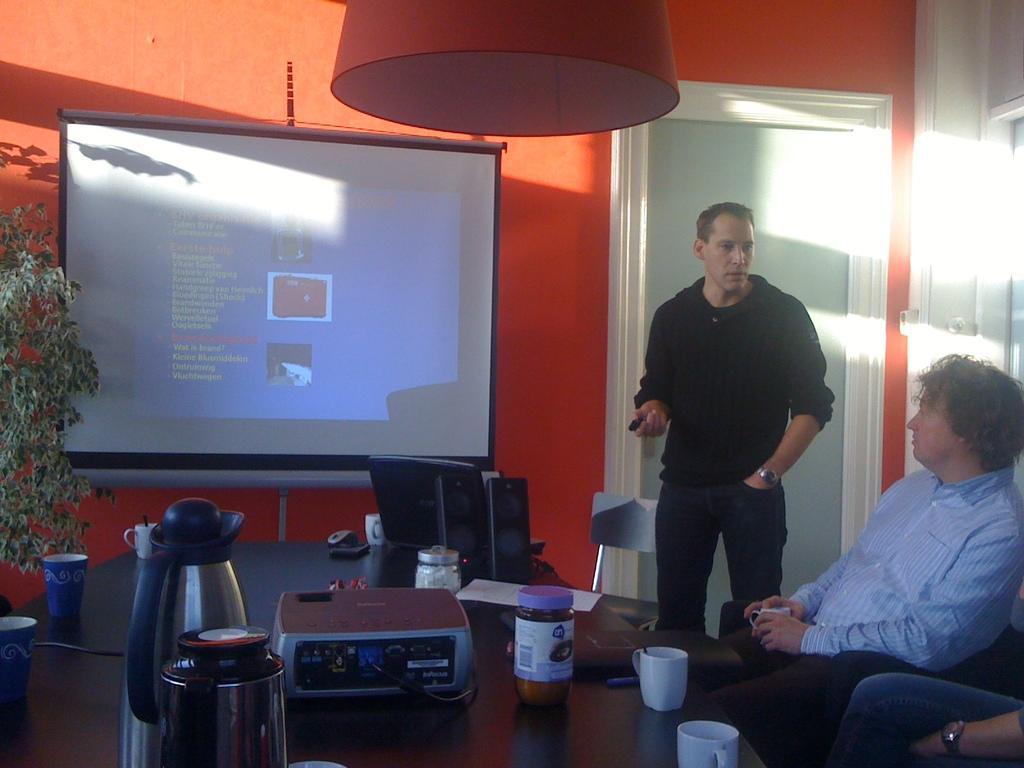Can you describe this image briefly? It looks like a room inside the office ,there is a projector screen and something is displayed on the screen, in front of that there is a black color table, on the table there is a flask, bottle, some cups and a projecting machine, to the right side that is a person sitting ,beside him there is a man standing and talking to him in the background there is orange color light and sunlight is falling on that wall. 